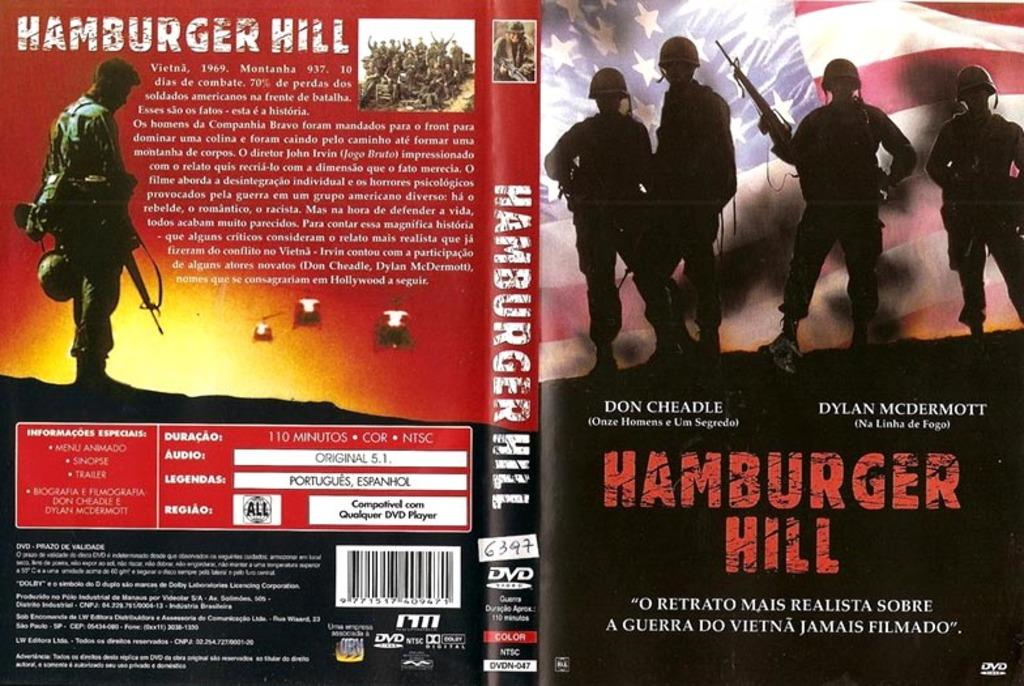Provide a one-sentence caption for the provided image. The front and back cover of a book called Hamburger Hill. 